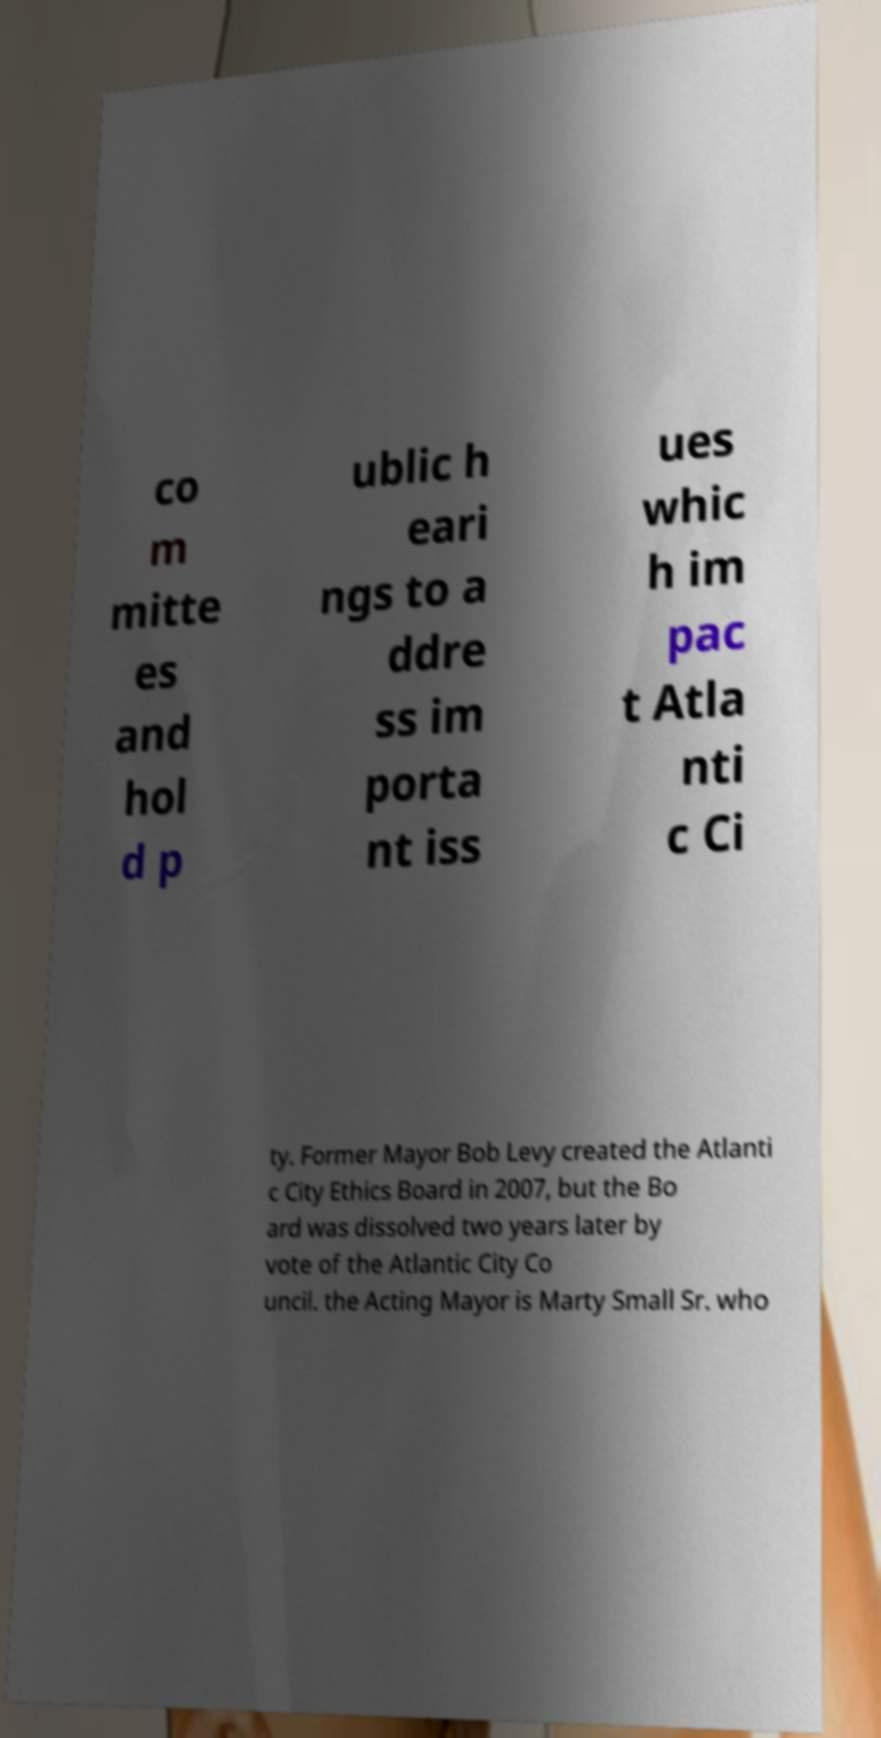There's text embedded in this image that I need extracted. Can you transcribe it verbatim? co m mitte es and hol d p ublic h eari ngs to a ddre ss im porta nt iss ues whic h im pac t Atla nti c Ci ty. Former Mayor Bob Levy created the Atlanti c City Ethics Board in 2007, but the Bo ard was dissolved two years later by vote of the Atlantic City Co uncil. the Acting Mayor is Marty Small Sr. who 